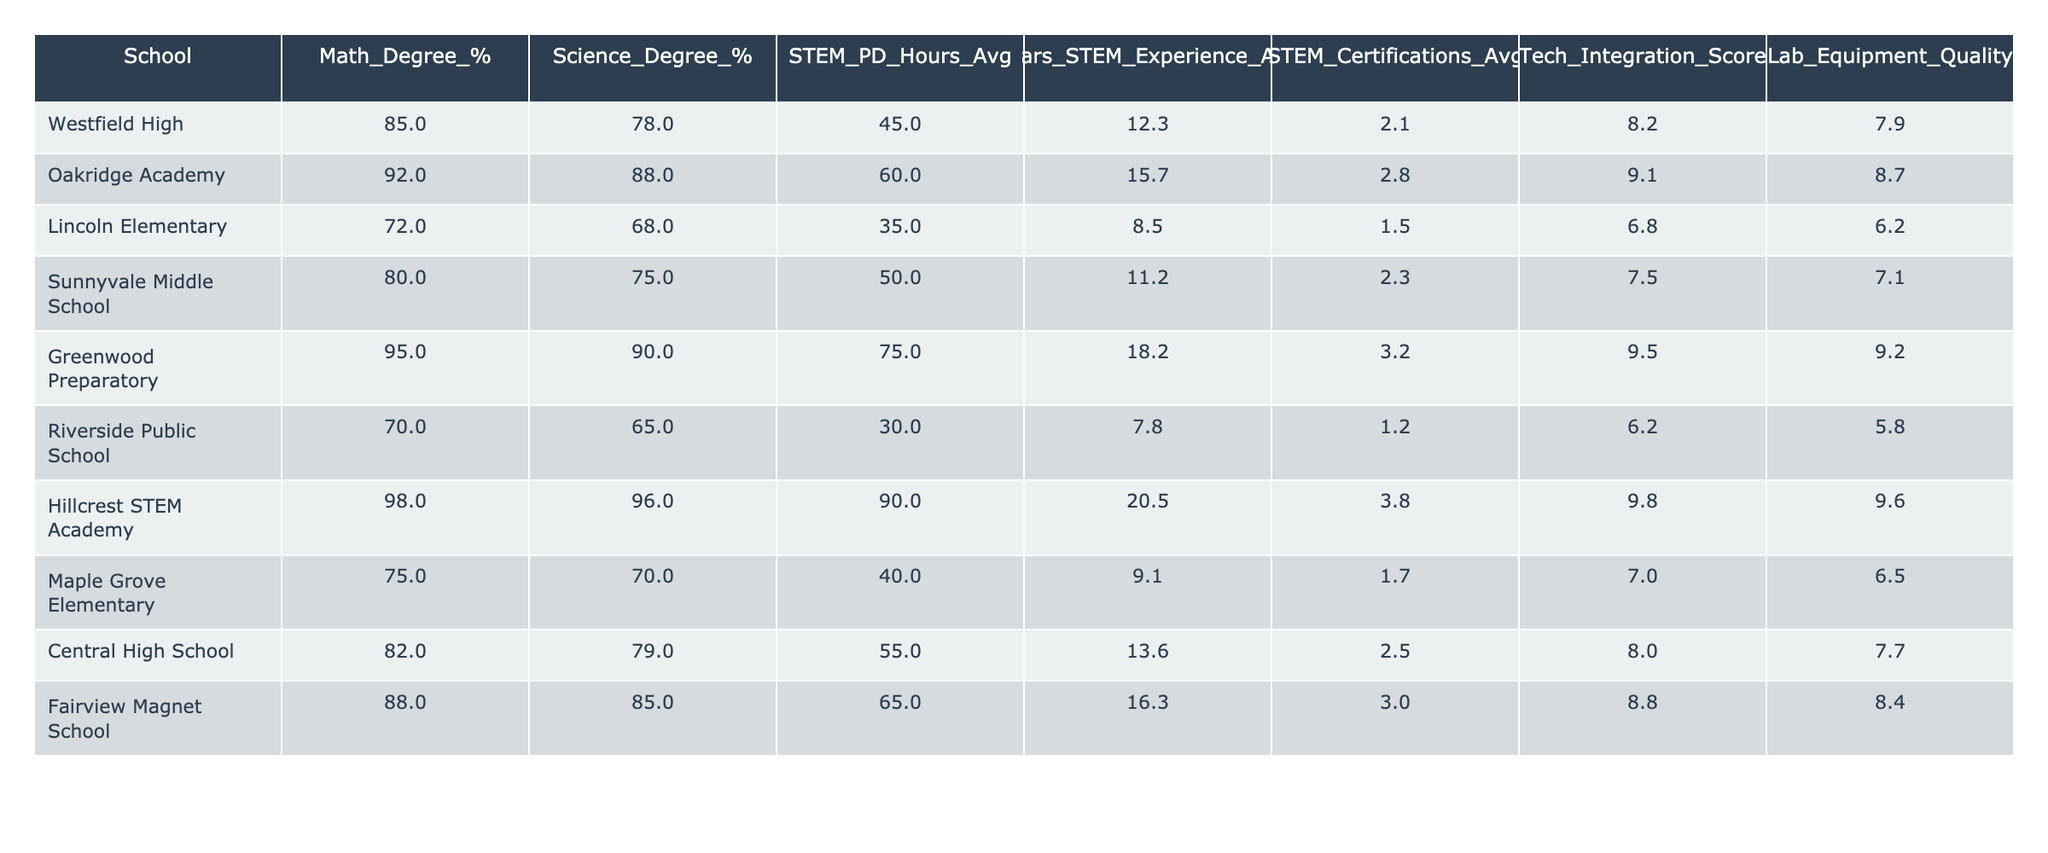What school has the highest percentage of teachers with a Math degree? By looking at the first column and the Math_Degree_% column, we can see that Hillcrest STEM Academy has the highest percentage at 98%.
Answer: Hillcrest STEM Academy Which school has the lowest average number of STEM professional development hours? The average STEM PD Hours column indicates that Riverside Public School has the lowest average with 30 hours.
Answer: Riverside Public School What is the average percentage of teachers with Science degrees across all schools? To calculate the average, sum the percentages of Science degrees (78 + 88 + 68 + 75 + 90 + 65 + 96 + 70 + 79 + 85) =  79.4 and divide by 10 (the number of schools) to find the average: 794/10 = 79.4%.
Answer: 79.4% Which school has the best Lab Equipment Quality score, and what is that score? By checking the Lab Equipment Quality column, we see that Greenwood Preparatory has the best score of 9.2.
Answer: Greenwood Preparatory, 9.2 Is it true that Oakridge Academy has more average STEM certifications than Lincoln Elementary? Comparing the STEM Certifications averages, Oakridge Academy has 2.8 while Lincoln Elementary has 1.5. Therefore, it is true that Oakridge Academy has more average STEM certifications.
Answer: Yes What is the difference in average years of STEM experience between the school with the maximum and minimum years? Hillcrest STEM Academy has 20.5 years, and Riverside Public School has 7.8 years. The difference is 20.5 - 7.8 = 12.7 years.
Answer: 12.7 years Which school has the highest Tech Integration Score, and how much higher is it than the average across all schools? Hillcrest STEM Academy has the highest Tech Integration Score of 9.8. The average Tech Integration Score calculated is (8.2 + 9.1 + 6.8 + 7.5 + 9.5 + 6.2 + 9.8 + 7.0 + 8.0 + 8.8) / 10 = 8.46. The difference is 9.8 - 8.46 = 1.34.
Answer: Hillcrest STEM Academy, 1.34 What is the total average percentage of teachers with degrees in both Math and Science? Total the Math Degree percentages (85 + 92 + 72 + 80 + 95 + 70 + 98 + 75 + 82 + 88) =  834, and for Science (78 + 88 + 68 + 75 + 90 + 65 + 96 + 70 + 79 + 85) =  79.4. Divide both by 10, resulting in 83.4 for Math and 79.4 for Science. The total average is (83.4 + 79.4) / 2 = 81.4%.
Answer: 81.4% 